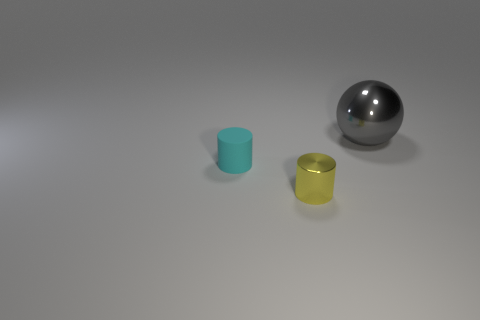Are there any other things that have the same shape as the large object?
Provide a short and direct response. No. Are there the same number of gray things to the right of the tiny shiny thing and matte cylinders?
Ensure brevity in your answer.  Yes. What number of other small yellow cylinders have the same material as the tiny yellow cylinder?
Your answer should be very brief. 0. What is the color of the sphere that is the same material as the yellow cylinder?
Give a very brief answer. Gray. Is the shape of the big object the same as the small cyan matte object?
Make the answer very short. No. There is a shiny object that is in front of the shiny object that is on the right side of the tiny metallic object; is there a object left of it?
Provide a short and direct response. Yes. There is a cyan matte thing that is the same size as the yellow shiny object; what is its shape?
Provide a succinct answer. Cylinder. Are there any small cylinders to the right of the gray metallic thing?
Keep it short and to the point. No. Do the gray shiny object and the cyan cylinder have the same size?
Your response must be concise. No. What shape is the tiny thing that is left of the small metallic cylinder?
Provide a short and direct response. Cylinder. 